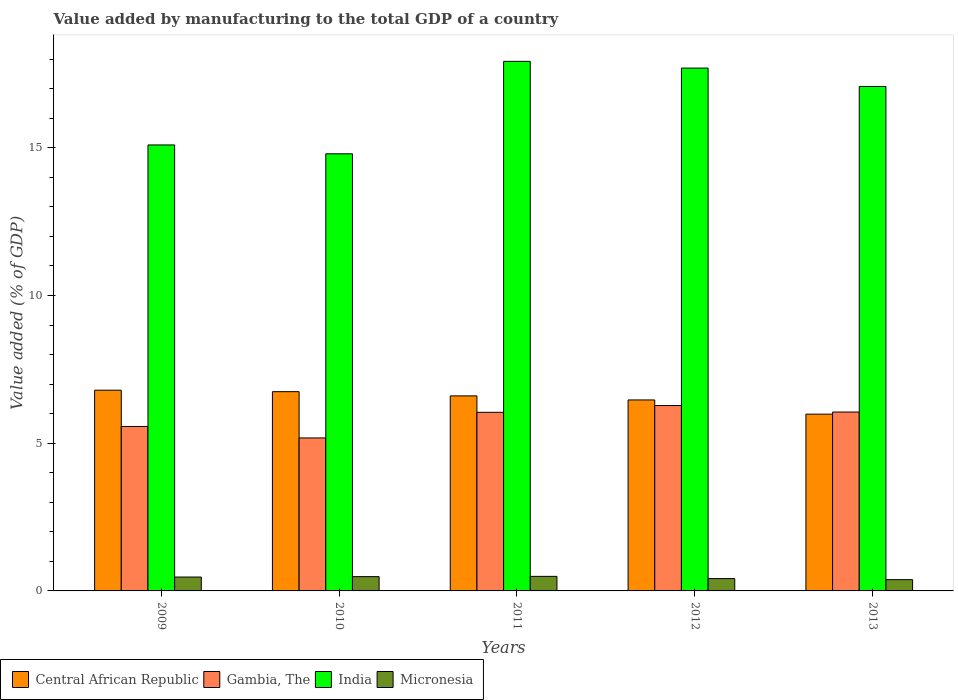How many different coloured bars are there?
Offer a terse response. 4. How many groups of bars are there?
Offer a terse response. 5. How many bars are there on the 4th tick from the right?
Offer a terse response. 4. What is the value added by manufacturing to the total GDP in Central African Republic in 2012?
Offer a terse response. 6.46. Across all years, what is the maximum value added by manufacturing to the total GDP in Micronesia?
Provide a succinct answer. 0.49. Across all years, what is the minimum value added by manufacturing to the total GDP in Central African Republic?
Give a very brief answer. 5.98. What is the total value added by manufacturing to the total GDP in India in the graph?
Give a very brief answer. 82.59. What is the difference between the value added by manufacturing to the total GDP in India in 2009 and that in 2012?
Make the answer very short. -2.6. What is the difference between the value added by manufacturing to the total GDP in India in 2010 and the value added by manufacturing to the total GDP in Gambia, The in 2009?
Offer a very short reply. 9.23. What is the average value added by manufacturing to the total GDP in Gambia, The per year?
Offer a terse response. 5.82. In the year 2010, what is the difference between the value added by manufacturing to the total GDP in Gambia, The and value added by manufacturing to the total GDP in Central African Republic?
Offer a terse response. -1.57. In how many years, is the value added by manufacturing to the total GDP in Gambia, The greater than 14 %?
Provide a short and direct response. 0. What is the ratio of the value added by manufacturing to the total GDP in Central African Republic in 2010 to that in 2011?
Offer a very short reply. 1.02. Is the difference between the value added by manufacturing to the total GDP in Gambia, The in 2009 and 2010 greater than the difference between the value added by manufacturing to the total GDP in Central African Republic in 2009 and 2010?
Make the answer very short. Yes. What is the difference between the highest and the second highest value added by manufacturing to the total GDP in Micronesia?
Provide a succinct answer. 0.01. What is the difference between the highest and the lowest value added by manufacturing to the total GDP in India?
Offer a very short reply. 3.13. In how many years, is the value added by manufacturing to the total GDP in Central African Republic greater than the average value added by manufacturing to the total GDP in Central African Republic taken over all years?
Give a very brief answer. 3. Is the sum of the value added by manufacturing to the total GDP in Gambia, The in 2009 and 2011 greater than the maximum value added by manufacturing to the total GDP in Micronesia across all years?
Keep it short and to the point. Yes. What does the 1st bar from the left in 2012 represents?
Provide a short and direct response. Central African Republic. What does the 1st bar from the right in 2013 represents?
Your answer should be very brief. Micronesia. Is it the case that in every year, the sum of the value added by manufacturing to the total GDP in Micronesia and value added by manufacturing to the total GDP in Gambia, The is greater than the value added by manufacturing to the total GDP in Central African Republic?
Offer a terse response. No. Are the values on the major ticks of Y-axis written in scientific E-notation?
Offer a terse response. No. Does the graph contain any zero values?
Offer a terse response. No. Does the graph contain grids?
Provide a succinct answer. No. How many legend labels are there?
Provide a short and direct response. 4. How are the legend labels stacked?
Your response must be concise. Horizontal. What is the title of the graph?
Offer a terse response. Value added by manufacturing to the total GDP of a country. What is the label or title of the X-axis?
Ensure brevity in your answer.  Years. What is the label or title of the Y-axis?
Ensure brevity in your answer.  Value added (% of GDP). What is the Value added (% of GDP) of Central African Republic in 2009?
Your answer should be compact. 6.79. What is the Value added (% of GDP) in Gambia, The in 2009?
Provide a short and direct response. 5.57. What is the Value added (% of GDP) in India in 2009?
Offer a very short reply. 15.1. What is the Value added (% of GDP) in Micronesia in 2009?
Offer a terse response. 0.47. What is the Value added (% of GDP) in Central African Republic in 2010?
Ensure brevity in your answer.  6.74. What is the Value added (% of GDP) of Gambia, The in 2010?
Give a very brief answer. 5.18. What is the Value added (% of GDP) in India in 2010?
Your answer should be compact. 14.8. What is the Value added (% of GDP) in Micronesia in 2010?
Your response must be concise. 0.48. What is the Value added (% of GDP) of Central African Republic in 2011?
Your response must be concise. 6.6. What is the Value added (% of GDP) of Gambia, The in 2011?
Give a very brief answer. 6.05. What is the Value added (% of GDP) in India in 2011?
Your answer should be very brief. 17.92. What is the Value added (% of GDP) of Micronesia in 2011?
Your answer should be very brief. 0.49. What is the Value added (% of GDP) of Central African Republic in 2012?
Your answer should be compact. 6.46. What is the Value added (% of GDP) in Gambia, The in 2012?
Offer a very short reply. 6.27. What is the Value added (% of GDP) in India in 2012?
Keep it short and to the point. 17.7. What is the Value added (% of GDP) of Micronesia in 2012?
Your response must be concise. 0.42. What is the Value added (% of GDP) in Central African Republic in 2013?
Keep it short and to the point. 5.98. What is the Value added (% of GDP) in Gambia, The in 2013?
Offer a very short reply. 6.05. What is the Value added (% of GDP) of India in 2013?
Provide a short and direct response. 17.08. What is the Value added (% of GDP) of Micronesia in 2013?
Provide a short and direct response. 0.38. Across all years, what is the maximum Value added (% of GDP) in Central African Republic?
Your answer should be very brief. 6.79. Across all years, what is the maximum Value added (% of GDP) of Gambia, The?
Provide a succinct answer. 6.27. Across all years, what is the maximum Value added (% of GDP) in India?
Keep it short and to the point. 17.92. Across all years, what is the maximum Value added (% of GDP) of Micronesia?
Your response must be concise. 0.49. Across all years, what is the minimum Value added (% of GDP) of Central African Republic?
Provide a succinct answer. 5.98. Across all years, what is the minimum Value added (% of GDP) of Gambia, The?
Offer a terse response. 5.18. Across all years, what is the minimum Value added (% of GDP) in India?
Offer a terse response. 14.8. Across all years, what is the minimum Value added (% of GDP) in Micronesia?
Give a very brief answer. 0.38. What is the total Value added (% of GDP) of Central African Republic in the graph?
Give a very brief answer. 32.59. What is the total Value added (% of GDP) in Gambia, The in the graph?
Give a very brief answer. 29.12. What is the total Value added (% of GDP) of India in the graph?
Ensure brevity in your answer.  82.59. What is the total Value added (% of GDP) of Micronesia in the graph?
Give a very brief answer. 2.25. What is the difference between the Value added (% of GDP) in Central African Republic in 2009 and that in 2010?
Give a very brief answer. 0.05. What is the difference between the Value added (% of GDP) in Gambia, The in 2009 and that in 2010?
Offer a terse response. 0.39. What is the difference between the Value added (% of GDP) in India in 2009 and that in 2010?
Make the answer very short. 0.3. What is the difference between the Value added (% of GDP) in Micronesia in 2009 and that in 2010?
Keep it short and to the point. -0.01. What is the difference between the Value added (% of GDP) in Central African Republic in 2009 and that in 2011?
Make the answer very short. 0.19. What is the difference between the Value added (% of GDP) of Gambia, The in 2009 and that in 2011?
Your response must be concise. -0.48. What is the difference between the Value added (% of GDP) of India in 2009 and that in 2011?
Give a very brief answer. -2.83. What is the difference between the Value added (% of GDP) of Micronesia in 2009 and that in 2011?
Your answer should be very brief. -0.02. What is the difference between the Value added (% of GDP) in Central African Republic in 2009 and that in 2012?
Provide a succinct answer. 0.33. What is the difference between the Value added (% of GDP) in Gambia, The in 2009 and that in 2012?
Offer a terse response. -0.71. What is the difference between the Value added (% of GDP) in India in 2009 and that in 2012?
Your answer should be compact. -2.6. What is the difference between the Value added (% of GDP) of Micronesia in 2009 and that in 2012?
Offer a terse response. 0.05. What is the difference between the Value added (% of GDP) in Central African Republic in 2009 and that in 2013?
Keep it short and to the point. 0.81. What is the difference between the Value added (% of GDP) of Gambia, The in 2009 and that in 2013?
Offer a terse response. -0.49. What is the difference between the Value added (% of GDP) of India in 2009 and that in 2013?
Give a very brief answer. -1.98. What is the difference between the Value added (% of GDP) of Micronesia in 2009 and that in 2013?
Make the answer very short. 0.09. What is the difference between the Value added (% of GDP) of Central African Republic in 2010 and that in 2011?
Provide a succinct answer. 0.14. What is the difference between the Value added (% of GDP) of Gambia, The in 2010 and that in 2011?
Your answer should be very brief. -0.87. What is the difference between the Value added (% of GDP) of India in 2010 and that in 2011?
Your answer should be very brief. -3.13. What is the difference between the Value added (% of GDP) of Micronesia in 2010 and that in 2011?
Give a very brief answer. -0.01. What is the difference between the Value added (% of GDP) of Central African Republic in 2010 and that in 2012?
Give a very brief answer. 0.28. What is the difference between the Value added (% of GDP) of Gambia, The in 2010 and that in 2012?
Give a very brief answer. -1.1. What is the difference between the Value added (% of GDP) of India in 2010 and that in 2012?
Provide a succinct answer. -2.9. What is the difference between the Value added (% of GDP) in Micronesia in 2010 and that in 2012?
Ensure brevity in your answer.  0.07. What is the difference between the Value added (% of GDP) of Central African Republic in 2010 and that in 2013?
Your answer should be compact. 0.76. What is the difference between the Value added (% of GDP) in Gambia, The in 2010 and that in 2013?
Your response must be concise. -0.88. What is the difference between the Value added (% of GDP) in India in 2010 and that in 2013?
Your answer should be very brief. -2.28. What is the difference between the Value added (% of GDP) of Micronesia in 2010 and that in 2013?
Offer a terse response. 0.1. What is the difference between the Value added (% of GDP) in Central African Republic in 2011 and that in 2012?
Your response must be concise. 0.14. What is the difference between the Value added (% of GDP) in Gambia, The in 2011 and that in 2012?
Your answer should be very brief. -0.23. What is the difference between the Value added (% of GDP) of India in 2011 and that in 2012?
Give a very brief answer. 0.23. What is the difference between the Value added (% of GDP) of Micronesia in 2011 and that in 2012?
Ensure brevity in your answer.  0.07. What is the difference between the Value added (% of GDP) in Central African Republic in 2011 and that in 2013?
Provide a short and direct response. 0.62. What is the difference between the Value added (% of GDP) in Gambia, The in 2011 and that in 2013?
Keep it short and to the point. -0.01. What is the difference between the Value added (% of GDP) in India in 2011 and that in 2013?
Your answer should be very brief. 0.85. What is the difference between the Value added (% of GDP) in Micronesia in 2011 and that in 2013?
Offer a very short reply. 0.11. What is the difference between the Value added (% of GDP) of Central African Republic in 2012 and that in 2013?
Offer a very short reply. 0.48. What is the difference between the Value added (% of GDP) in Gambia, The in 2012 and that in 2013?
Offer a very short reply. 0.22. What is the difference between the Value added (% of GDP) in India in 2012 and that in 2013?
Make the answer very short. 0.62. What is the difference between the Value added (% of GDP) of Micronesia in 2012 and that in 2013?
Provide a succinct answer. 0.04. What is the difference between the Value added (% of GDP) of Central African Republic in 2009 and the Value added (% of GDP) of Gambia, The in 2010?
Provide a short and direct response. 1.62. What is the difference between the Value added (% of GDP) in Central African Republic in 2009 and the Value added (% of GDP) in India in 2010?
Provide a short and direct response. -8. What is the difference between the Value added (% of GDP) in Central African Republic in 2009 and the Value added (% of GDP) in Micronesia in 2010?
Keep it short and to the point. 6.31. What is the difference between the Value added (% of GDP) in Gambia, The in 2009 and the Value added (% of GDP) in India in 2010?
Offer a very short reply. -9.23. What is the difference between the Value added (% of GDP) of Gambia, The in 2009 and the Value added (% of GDP) of Micronesia in 2010?
Offer a terse response. 5.08. What is the difference between the Value added (% of GDP) in India in 2009 and the Value added (% of GDP) in Micronesia in 2010?
Give a very brief answer. 14.61. What is the difference between the Value added (% of GDP) in Central African Republic in 2009 and the Value added (% of GDP) in Gambia, The in 2011?
Offer a terse response. 0.75. What is the difference between the Value added (% of GDP) of Central African Republic in 2009 and the Value added (% of GDP) of India in 2011?
Your answer should be compact. -11.13. What is the difference between the Value added (% of GDP) in Central African Republic in 2009 and the Value added (% of GDP) in Micronesia in 2011?
Keep it short and to the point. 6.3. What is the difference between the Value added (% of GDP) of Gambia, The in 2009 and the Value added (% of GDP) of India in 2011?
Offer a very short reply. -12.36. What is the difference between the Value added (% of GDP) of Gambia, The in 2009 and the Value added (% of GDP) of Micronesia in 2011?
Ensure brevity in your answer.  5.07. What is the difference between the Value added (% of GDP) in India in 2009 and the Value added (% of GDP) in Micronesia in 2011?
Provide a succinct answer. 14.6. What is the difference between the Value added (% of GDP) in Central African Republic in 2009 and the Value added (% of GDP) in Gambia, The in 2012?
Offer a very short reply. 0.52. What is the difference between the Value added (% of GDP) of Central African Republic in 2009 and the Value added (% of GDP) of India in 2012?
Keep it short and to the point. -10.9. What is the difference between the Value added (% of GDP) of Central African Republic in 2009 and the Value added (% of GDP) of Micronesia in 2012?
Offer a very short reply. 6.38. What is the difference between the Value added (% of GDP) in Gambia, The in 2009 and the Value added (% of GDP) in India in 2012?
Make the answer very short. -12.13. What is the difference between the Value added (% of GDP) in Gambia, The in 2009 and the Value added (% of GDP) in Micronesia in 2012?
Your answer should be very brief. 5.15. What is the difference between the Value added (% of GDP) in India in 2009 and the Value added (% of GDP) in Micronesia in 2012?
Offer a terse response. 14.68. What is the difference between the Value added (% of GDP) of Central African Republic in 2009 and the Value added (% of GDP) of Gambia, The in 2013?
Your answer should be very brief. 0.74. What is the difference between the Value added (% of GDP) of Central African Republic in 2009 and the Value added (% of GDP) of India in 2013?
Your answer should be compact. -10.28. What is the difference between the Value added (% of GDP) of Central African Republic in 2009 and the Value added (% of GDP) of Micronesia in 2013?
Your answer should be compact. 6.41. What is the difference between the Value added (% of GDP) of Gambia, The in 2009 and the Value added (% of GDP) of India in 2013?
Your answer should be very brief. -11.51. What is the difference between the Value added (% of GDP) of Gambia, The in 2009 and the Value added (% of GDP) of Micronesia in 2013?
Make the answer very short. 5.18. What is the difference between the Value added (% of GDP) of India in 2009 and the Value added (% of GDP) of Micronesia in 2013?
Provide a short and direct response. 14.71. What is the difference between the Value added (% of GDP) in Central African Republic in 2010 and the Value added (% of GDP) in Gambia, The in 2011?
Offer a very short reply. 0.7. What is the difference between the Value added (% of GDP) in Central African Republic in 2010 and the Value added (% of GDP) in India in 2011?
Your answer should be very brief. -11.18. What is the difference between the Value added (% of GDP) in Central African Republic in 2010 and the Value added (% of GDP) in Micronesia in 2011?
Provide a short and direct response. 6.25. What is the difference between the Value added (% of GDP) of Gambia, The in 2010 and the Value added (% of GDP) of India in 2011?
Ensure brevity in your answer.  -12.75. What is the difference between the Value added (% of GDP) in Gambia, The in 2010 and the Value added (% of GDP) in Micronesia in 2011?
Keep it short and to the point. 4.69. What is the difference between the Value added (% of GDP) of India in 2010 and the Value added (% of GDP) of Micronesia in 2011?
Provide a short and direct response. 14.3. What is the difference between the Value added (% of GDP) in Central African Republic in 2010 and the Value added (% of GDP) in Gambia, The in 2012?
Offer a very short reply. 0.47. What is the difference between the Value added (% of GDP) in Central African Republic in 2010 and the Value added (% of GDP) in India in 2012?
Keep it short and to the point. -10.95. What is the difference between the Value added (% of GDP) of Central African Republic in 2010 and the Value added (% of GDP) of Micronesia in 2012?
Provide a short and direct response. 6.33. What is the difference between the Value added (% of GDP) of Gambia, The in 2010 and the Value added (% of GDP) of India in 2012?
Offer a terse response. -12.52. What is the difference between the Value added (% of GDP) in Gambia, The in 2010 and the Value added (% of GDP) in Micronesia in 2012?
Your answer should be compact. 4.76. What is the difference between the Value added (% of GDP) in India in 2010 and the Value added (% of GDP) in Micronesia in 2012?
Your response must be concise. 14.38. What is the difference between the Value added (% of GDP) of Central African Republic in 2010 and the Value added (% of GDP) of Gambia, The in 2013?
Offer a terse response. 0.69. What is the difference between the Value added (% of GDP) in Central African Republic in 2010 and the Value added (% of GDP) in India in 2013?
Provide a succinct answer. -10.33. What is the difference between the Value added (% of GDP) in Central African Republic in 2010 and the Value added (% of GDP) in Micronesia in 2013?
Give a very brief answer. 6.36. What is the difference between the Value added (% of GDP) of Gambia, The in 2010 and the Value added (% of GDP) of India in 2013?
Ensure brevity in your answer.  -11.9. What is the difference between the Value added (% of GDP) in Gambia, The in 2010 and the Value added (% of GDP) in Micronesia in 2013?
Offer a terse response. 4.8. What is the difference between the Value added (% of GDP) of India in 2010 and the Value added (% of GDP) of Micronesia in 2013?
Keep it short and to the point. 14.41. What is the difference between the Value added (% of GDP) in Central African Republic in 2011 and the Value added (% of GDP) in Gambia, The in 2012?
Your response must be concise. 0.33. What is the difference between the Value added (% of GDP) of Central African Republic in 2011 and the Value added (% of GDP) of India in 2012?
Provide a short and direct response. -11.1. What is the difference between the Value added (% of GDP) in Central African Republic in 2011 and the Value added (% of GDP) in Micronesia in 2012?
Provide a short and direct response. 6.18. What is the difference between the Value added (% of GDP) of Gambia, The in 2011 and the Value added (% of GDP) of India in 2012?
Keep it short and to the point. -11.65. What is the difference between the Value added (% of GDP) in Gambia, The in 2011 and the Value added (% of GDP) in Micronesia in 2012?
Provide a succinct answer. 5.63. What is the difference between the Value added (% of GDP) of India in 2011 and the Value added (% of GDP) of Micronesia in 2012?
Keep it short and to the point. 17.51. What is the difference between the Value added (% of GDP) in Central African Republic in 2011 and the Value added (% of GDP) in Gambia, The in 2013?
Your response must be concise. 0.55. What is the difference between the Value added (% of GDP) in Central African Republic in 2011 and the Value added (% of GDP) in India in 2013?
Offer a very short reply. -10.47. What is the difference between the Value added (% of GDP) of Central African Republic in 2011 and the Value added (% of GDP) of Micronesia in 2013?
Make the answer very short. 6.22. What is the difference between the Value added (% of GDP) in Gambia, The in 2011 and the Value added (% of GDP) in India in 2013?
Your answer should be very brief. -11.03. What is the difference between the Value added (% of GDP) in Gambia, The in 2011 and the Value added (% of GDP) in Micronesia in 2013?
Make the answer very short. 5.66. What is the difference between the Value added (% of GDP) in India in 2011 and the Value added (% of GDP) in Micronesia in 2013?
Offer a very short reply. 17.54. What is the difference between the Value added (% of GDP) in Central African Republic in 2012 and the Value added (% of GDP) in Gambia, The in 2013?
Keep it short and to the point. 0.41. What is the difference between the Value added (% of GDP) in Central African Republic in 2012 and the Value added (% of GDP) in India in 2013?
Your answer should be very brief. -10.61. What is the difference between the Value added (% of GDP) in Central African Republic in 2012 and the Value added (% of GDP) in Micronesia in 2013?
Offer a terse response. 6.08. What is the difference between the Value added (% of GDP) of Gambia, The in 2012 and the Value added (% of GDP) of India in 2013?
Provide a short and direct response. -10.8. What is the difference between the Value added (% of GDP) in Gambia, The in 2012 and the Value added (% of GDP) in Micronesia in 2013?
Offer a terse response. 5.89. What is the difference between the Value added (% of GDP) in India in 2012 and the Value added (% of GDP) in Micronesia in 2013?
Give a very brief answer. 17.31. What is the average Value added (% of GDP) in Central African Republic per year?
Your answer should be compact. 6.52. What is the average Value added (% of GDP) of Gambia, The per year?
Your answer should be compact. 5.82. What is the average Value added (% of GDP) in India per year?
Your answer should be compact. 16.52. What is the average Value added (% of GDP) of Micronesia per year?
Keep it short and to the point. 0.45. In the year 2009, what is the difference between the Value added (% of GDP) of Central African Republic and Value added (% of GDP) of Gambia, The?
Give a very brief answer. 1.23. In the year 2009, what is the difference between the Value added (% of GDP) in Central African Republic and Value added (% of GDP) in India?
Provide a succinct answer. -8.3. In the year 2009, what is the difference between the Value added (% of GDP) in Central African Republic and Value added (% of GDP) in Micronesia?
Your response must be concise. 6.32. In the year 2009, what is the difference between the Value added (% of GDP) of Gambia, The and Value added (% of GDP) of India?
Keep it short and to the point. -9.53. In the year 2009, what is the difference between the Value added (% of GDP) in Gambia, The and Value added (% of GDP) in Micronesia?
Keep it short and to the point. 5.1. In the year 2009, what is the difference between the Value added (% of GDP) in India and Value added (% of GDP) in Micronesia?
Give a very brief answer. 14.63. In the year 2010, what is the difference between the Value added (% of GDP) of Central African Republic and Value added (% of GDP) of Gambia, The?
Ensure brevity in your answer.  1.57. In the year 2010, what is the difference between the Value added (% of GDP) in Central African Republic and Value added (% of GDP) in India?
Your response must be concise. -8.05. In the year 2010, what is the difference between the Value added (% of GDP) in Central African Republic and Value added (% of GDP) in Micronesia?
Your answer should be compact. 6.26. In the year 2010, what is the difference between the Value added (% of GDP) in Gambia, The and Value added (% of GDP) in India?
Your answer should be very brief. -9.62. In the year 2010, what is the difference between the Value added (% of GDP) in Gambia, The and Value added (% of GDP) in Micronesia?
Keep it short and to the point. 4.69. In the year 2010, what is the difference between the Value added (% of GDP) of India and Value added (% of GDP) of Micronesia?
Your answer should be very brief. 14.31. In the year 2011, what is the difference between the Value added (% of GDP) in Central African Republic and Value added (% of GDP) in Gambia, The?
Offer a very short reply. 0.56. In the year 2011, what is the difference between the Value added (% of GDP) of Central African Republic and Value added (% of GDP) of India?
Provide a succinct answer. -11.32. In the year 2011, what is the difference between the Value added (% of GDP) in Central African Republic and Value added (% of GDP) in Micronesia?
Keep it short and to the point. 6.11. In the year 2011, what is the difference between the Value added (% of GDP) in Gambia, The and Value added (% of GDP) in India?
Your answer should be compact. -11.88. In the year 2011, what is the difference between the Value added (% of GDP) of Gambia, The and Value added (% of GDP) of Micronesia?
Your answer should be very brief. 5.55. In the year 2011, what is the difference between the Value added (% of GDP) in India and Value added (% of GDP) in Micronesia?
Provide a short and direct response. 17.43. In the year 2012, what is the difference between the Value added (% of GDP) of Central African Republic and Value added (% of GDP) of Gambia, The?
Provide a short and direct response. 0.19. In the year 2012, what is the difference between the Value added (% of GDP) in Central African Republic and Value added (% of GDP) in India?
Make the answer very short. -11.23. In the year 2012, what is the difference between the Value added (% of GDP) in Central African Republic and Value added (% of GDP) in Micronesia?
Provide a short and direct response. 6.05. In the year 2012, what is the difference between the Value added (% of GDP) in Gambia, The and Value added (% of GDP) in India?
Provide a succinct answer. -11.42. In the year 2012, what is the difference between the Value added (% of GDP) of Gambia, The and Value added (% of GDP) of Micronesia?
Offer a terse response. 5.86. In the year 2012, what is the difference between the Value added (% of GDP) of India and Value added (% of GDP) of Micronesia?
Make the answer very short. 17.28. In the year 2013, what is the difference between the Value added (% of GDP) in Central African Republic and Value added (% of GDP) in Gambia, The?
Offer a terse response. -0.07. In the year 2013, what is the difference between the Value added (% of GDP) in Central African Republic and Value added (% of GDP) in India?
Provide a short and direct response. -11.09. In the year 2013, what is the difference between the Value added (% of GDP) of Central African Republic and Value added (% of GDP) of Micronesia?
Your response must be concise. 5.6. In the year 2013, what is the difference between the Value added (% of GDP) in Gambia, The and Value added (% of GDP) in India?
Keep it short and to the point. -11.02. In the year 2013, what is the difference between the Value added (% of GDP) in Gambia, The and Value added (% of GDP) in Micronesia?
Offer a very short reply. 5.67. In the year 2013, what is the difference between the Value added (% of GDP) in India and Value added (% of GDP) in Micronesia?
Make the answer very short. 16.69. What is the ratio of the Value added (% of GDP) in Central African Republic in 2009 to that in 2010?
Offer a terse response. 1.01. What is the ratio of the Value added (% of GDP) of Gambia, The in 2009 to that in 2010?
Make the answer very short. 1.07. What is the ratio of the Value added (% of GDP) in India in 2009 to that in 2010?
Provide a short and direct response. 1.02. What is the ratio of the Value added (% of GDP) in Micronesia in 2009 to that in 2010?
Give a very brief answer. 0.97. What is the ratio of the Value added (% of GDP) of Central African Republic in 2009 to that in 2011?
Ensure brevity in your answer.  1.03. What is the ratio of the Value added (% of GDP) of Gambia, The in 2009 to that in 2011?
Your answer should be compact. 0.92. What is the ratio of the Value added (% of GDP) in India in 2009 to that in 2011?
Offer a very short reply. 0.84. What is the ratio of the Value added (% of GDP) in Micronesia in 2009 to that in 2011?
Make the answer very short. 0.95. What is the ratio of the Value added (% of GDP) in Central African Republic in 2009 to that in 2012?
Your answer should be very brief. 1.05. What is the ratio of the Value added (% of GDP) in Gambia, The in 2009 to that in 2012?
Make the answer very short. 0.89. What is the ratio of the Value added (% of GDP) of India in 2009 to that in 2012?
Provide a succinct answer. 0.85. What is the ratio of the Value added (% of GDP) of Micronesia in 2009 to that in 2012?
Your response must be concise. 1.12. What is the ratio of the Value added (% of GDP) of Central African Republic in 2009 to that in 2013?
Your answer should be very brief. 1.14. What is the ratio of the Value added (% of GDP) in Gambia, The in 2009 to that in 2013?
Your answer should be very brief. 0.92. What is the ratio of the Value added (% of GDP) in India in 2009 to that in 2013?
Your answer should be very brief. 0.88. What is the ratio of the Value added (% of GDP) of Micronesia in 2009 to that in 2013?
Provide a succinct answer. 1.23. What is the ratio of the Value added (% of GDP) in Central African Republic in 2010 to that in 2011?
Ensure brevity in your answer.  1.02. What is the ratio of the Value added (% of GDP) of Gambia, The in 2010 to that in 2011?
Offer a very short reply. 0.86. What is the ratio of the Value added (% of GDP) in India in 2010 to that in 2011?
Offer a very short reply. 0.83. What is the ratio of the Value added (% of GDP) of Micronesia in 2010 to that in 2011?
Your response must be concise. 0.98. What is the ratio of the Value added (% of GDP) in Central African Republic in 2010 to that in 2012?
Provide a succinct answer. 1.04. What is the ratio of the Value added (% of GDP) of Gambia, The in 2010 to that in 2012?
Ensure brevity in your answer.  0.83. What is the ratio of the Value added (% of GDP) of India in 2010 to that in 2012?
Give a very brief answer. 0.84. What is the ratio of the Value added (% of GDP) of Micronesia in 2010 to that in 2012?
Your answer should be compact. 1.16. What is the ratio of the Value added (% of GDP) in Central African Republic in 2010 to that in 2013?
Ensure brevity in your answer.  1.13. What is the ratio of the Value added (% of GDP) of Gambia, The in 2010 to that in 2013?
Offer a very short reply. 0.86. What is the ratio of the Value added (% of GDP) in India in 2010 to that in 2013?
Give a very brief answer. 0.87. What is the ratio of the Value added (% of GDP) in Micronesia in 2010 to that in 2013?
Ensure brevity in your answer.  1.27. What is the ratio of the Value added (% of GDP) in Central African Republic in 2011 to that in 2012?
Keep it short and to the point. 1.02. What is the ratio of the Value added (% of GDP) in Gambia, The in 2011 to that in 2012?
Provide a short and direct response. 0.96. What is the ratio of the Value added (% of GDP) in India in 2011 to that in 2012?
Your response must be concise. 1.01. What is the ratio of the Value added (% of GDP) of Micronesia in 2011 to that in 2012?
Make the answer very short. 1.18. What is the ratio of the Value added (% of GDP) in Central African Republic in 2011 to that in 2013?
Your answer should be compact. 1.1. What is the ratio of the Value added (% of GDP) in Gambia, The in 2011 to that in 2013?
Provide a succinct answer. 1. What is the ratio of the Value added (% of GDP) of India in 2011 to that in 2013?
Give a very brief answer. 1.05. What is the ratio of the Value added (% of GDP) in Micronesia in 2011 to that in 2013?
Offer a very short reply. 1.29. What is the ratio of the Value added (% of GDP) in Central African Republic in 2012 to that in 2013?
Provide a succinct answer. 1.08. What is the ratio of the Value added (% of GDP) of Gambia, The in 2012 to that in 2013?
Provide a succinct answer. 1.04. What is the ratio of the Value added (% of GDP) of India in 2012 to that in 2013?
Ensure brevity in your answer.  1.04. What is the ratio of the Value added (% of GDP) of Micronesia in 2012 to that in 2013?
Your answer should be compact. 1.09. What is the difference between the highest and the second highest Value added (% of GDP) of Central African Republic?
Offer a terse response. 0.05. What is the difference between the highest and the second highest Value added (% of GDP) in Gambia, The?
Provide a short and direct response. 0.22. What is the difference between the highest and the second highest Value added (% of GDP) of India?
Keep it short and to the point. 0.23. What is the difference between the highest and the second highest Value added (% of GDP) of Micronesia?
Ensure brevity in your answer.  0.01. What is the difference between the highest and the lowest Value added (% of GDP) in Central African Republic?
Provide a short and direct response. 0.81. What is the difference between the highest and the lowest Value added (% of GDP) in Gambia, The?
Offer a very short reply. 1.1. What is the difference between the highest and the lowest Value added (% of GDP) in India?
Keep it short and to the point. 3.13. What is the difference between the highest and the lowest Value added (% of GDP) in Micronesia?
Offer a very short reply. 0.11. 